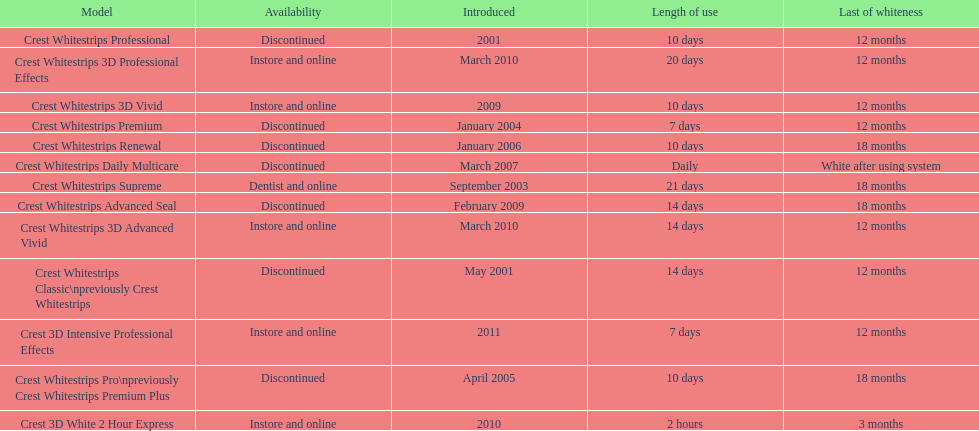How many products have been discontinued? 7. 